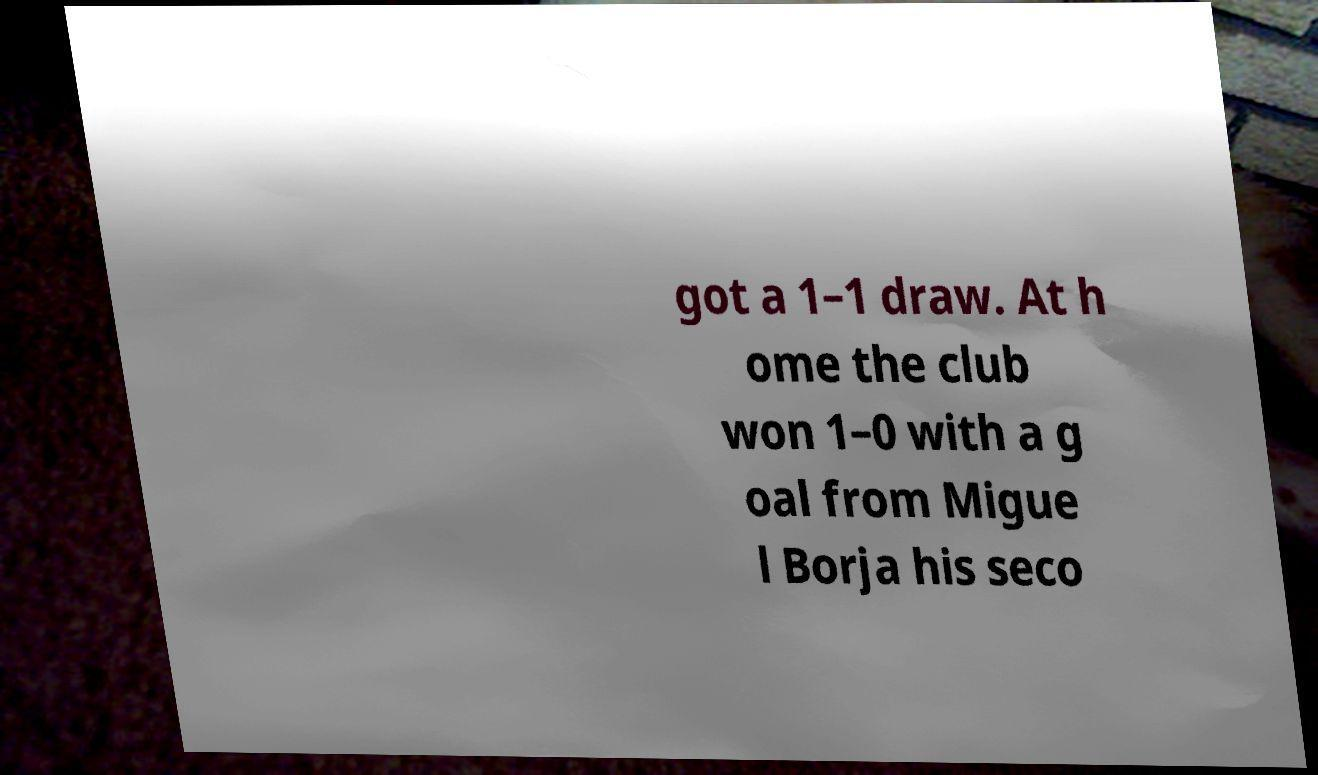Can you accurately transcribe the text from the provided image for me? got a 1–1 draw. At h ome the club won 1–0 with a g oal from Migue l Borja his seco 